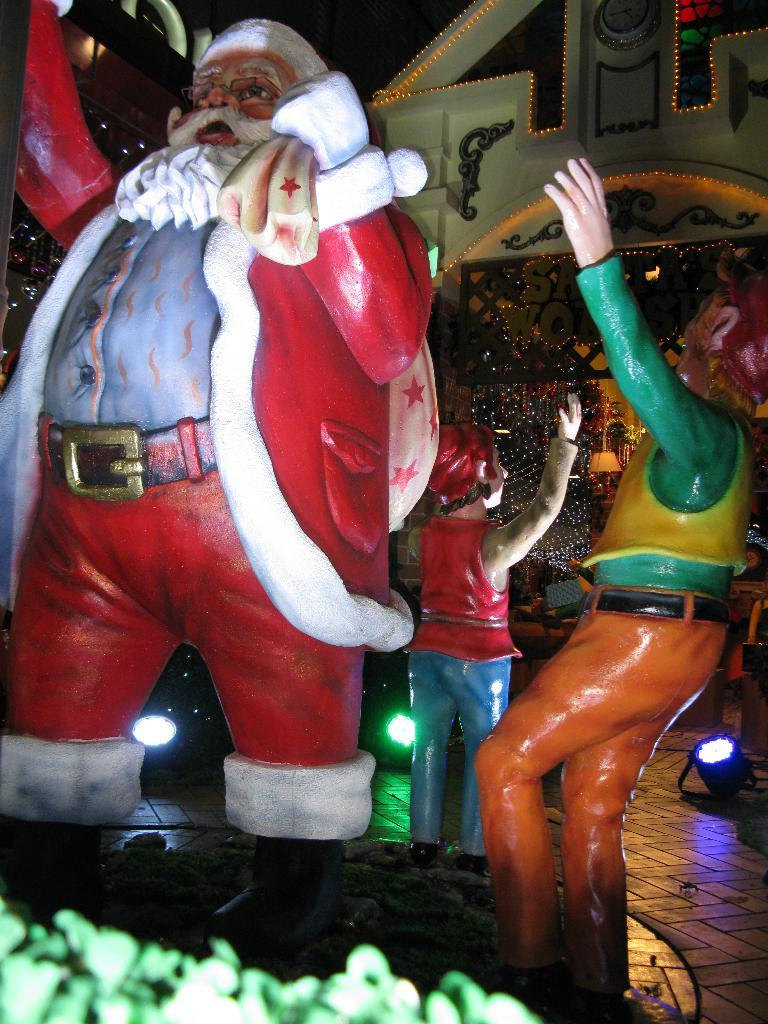What can be seen in the image besides the building in the background? There are statues in the image. What type of lighting is present in the image? Focusing lights are present in the image. What book is the person holding in the image? There is no person holding a book in the image; it features statues and a building in the background. What is the angle of the person's elbow in the image? There is no person present in the image, so the angle of their elbow cannot be determined. 